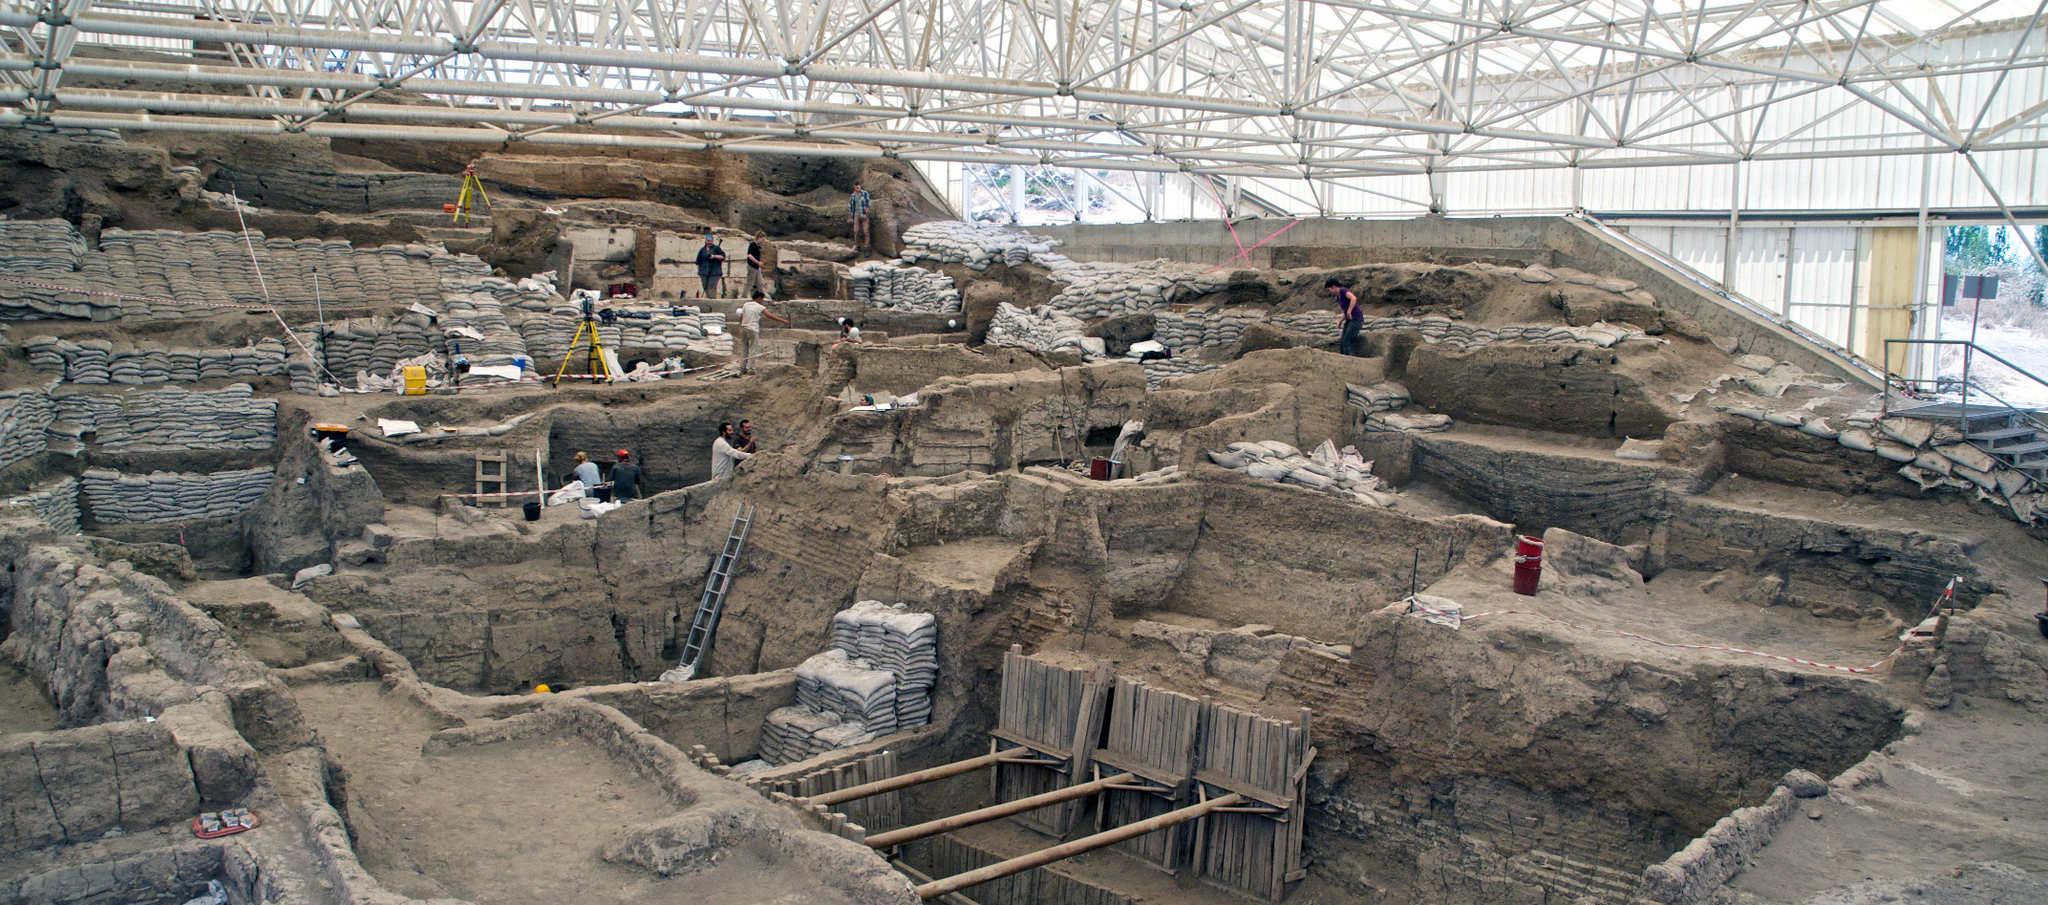Can you explain the significance of the structures and artifacts found at Catalhoyuk? Absolutely, the structures and artifacts at Catalhoyuk provide profound insights into early Neolithic life. The site is remarkable for its dense cluster of mud-brick houses with no streets; instead, entrances were likely through roofs, suggesting a unique community layout emphasizing security and communal living. Artifacts like figurines, pottery, and wall paintings suggest a complex society rich in cultural practices and beliefs, possibly centered around mother goddess worship and intricate burial rituals. These findings help historians trace the evolution of social organization, religious practices, and daily life in one of humanity's earliest urban-like settlements. 